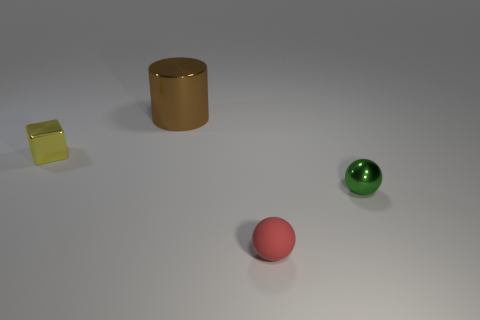Are there the same number of small yellow shiny blocks right of the green thing and big brown shiny things that are on the left side of the large brown shiny cylinder?
Ensure brevity in your answer.  Yes. There is a small thing that is on the left side of the green metal sphere and on the right side of the shiny block; what material is it?
Offer a terse response. Rubber. Does the brown object have the same size as the shiny object that is in front of the tiny yellow cube?
Keep it short and to the point. No. What number of other objects are there of the same color as the cube?
Provide a short and direct response. 0. Is the number of small yellow metallic blocks that are in front of the small green metal thing greater than the number of brown things?
Provide a short and direct response. No. There is a small sphere left of the shiny object in front of the yellow metal block left of the small green thing; what is its color?
Ensure brevity in your answer.  Red. Is the small yellow object made of the same material as the green thing?
Your response must be concise. Yes. Are there any red matte balls of the same size as the green sphere?
Your response must be concise. Yes. There is a ball that is the same size as the green object; what is its material?
Give a very brief answer. Rubber. Are there any small purple metal objects of the same shape as the large brown metallic object?
Give a very brief answer. No. 